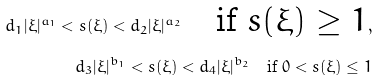Convert formula to latex. <formula><loc_0><loc_0><loc_500><loc_500>d _ { 1 } | \xi | ^ { a _ { 1 } } < s ( \xi ) < d _ { 2 } | \xi | ^ { a _ { 2 } } \quad \text {if $s(\xi)\geq 1$} , \\ d _ { 3 } | \xi | ^ { b _ { 1 } } < s ( \xi ) < d _ { 4 } | \xi | ^ { b _ { 2 } } \quad \text {if $0<s(\xi)\leq 1$}</formula> 